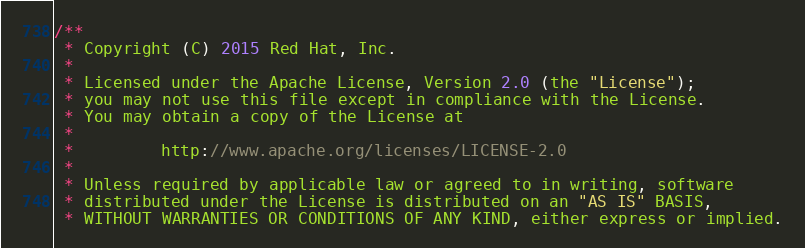<code> <loc_0><loc_0><loc_500><loc_500><_Go_>/**
 * Copyright (C) 2015 Red Hat, Inc.
 *
 * Licensed under the Apache License, Version 2.0 (the "License");
 * you may not use this file except in compliance with the License.
 * You may obtain a copy of the License at
 *
 *         http://www.apache.org/licenses/LICENSE-2.0
 *
 * Unless required by applicable law or agreed to in writing, software
 * distributed under the License is distributed on an "AS IS" BASIS,
 * WITHOUT WARRANTIES OR CONDITIONS OF ANY KIND, either express or implied.</code> 